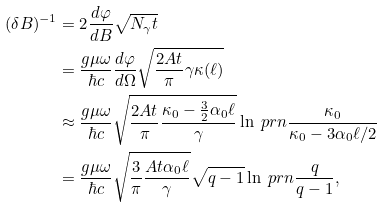Convert formula to latex. <formula><loc_0><loc_0><loc_500><loc_500>( \delta B ) ^ { - 1 } & = 2 \frac { d \varphi } { d B } \sqrt { N _ { \gamma } t } \\ & = \frac { g \mu \omega } { \hbar { c } } \frac { d \varphi } { d \Omega } \sqrt { \frac { 2 A t } { \pi } \gamma \kappa ( \ell ) } \\ & \approx \frac { g \mu \omega } { \hbar { c } } \sqrt { \frac { 2 A t } { \pi } \frac { \kappa _ { 0 } - \frac { 3 } { 2 } \alpha _ { 0 } \ell } { \gamma } } \ln \ p r n { \frac { \kappa _ { 0 } } { \kappa _ { 0 } - 3 \alpha _ { 0 } \ell / 2 } } \\ & = \frac { g \mu \omega } { \hbar { c } } \sqrt { \frac { 3 } { \pi } \frac { A t \alpha _ { 0 } \ell } { \gamma } } \sqrt { q - 1 } \ln \ p r n { \frac { q } { q - 1 } } ,</formula> 